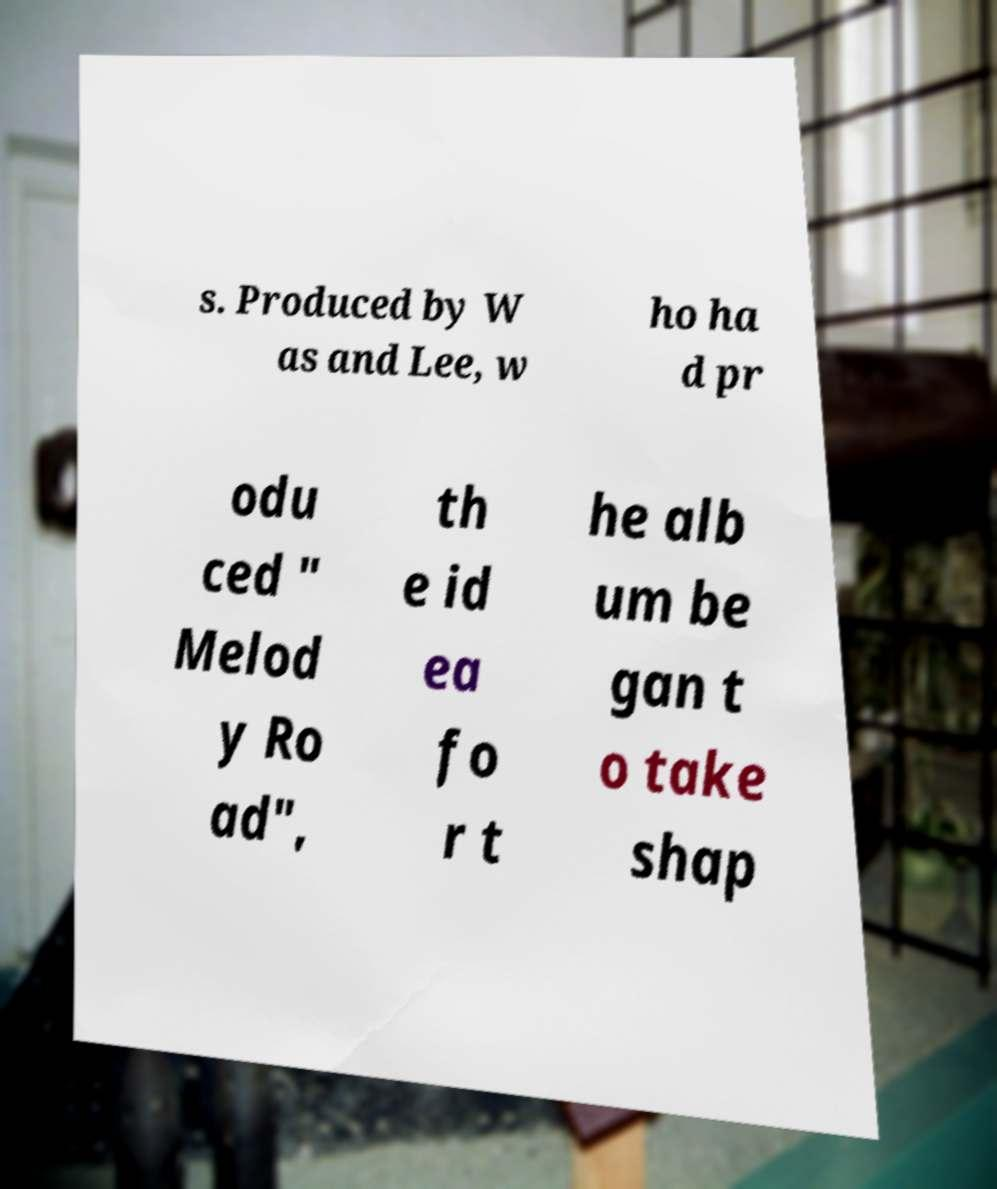Can you read and provide the text displayed in the image?This photo seems to have some interesting text. Can you extract and type it out for me? s. Produced by W as and Lee, w ho ha d pr odu ced " Melod y Ro ad", th e id ea fo r t he alb um be gan t o take shap 